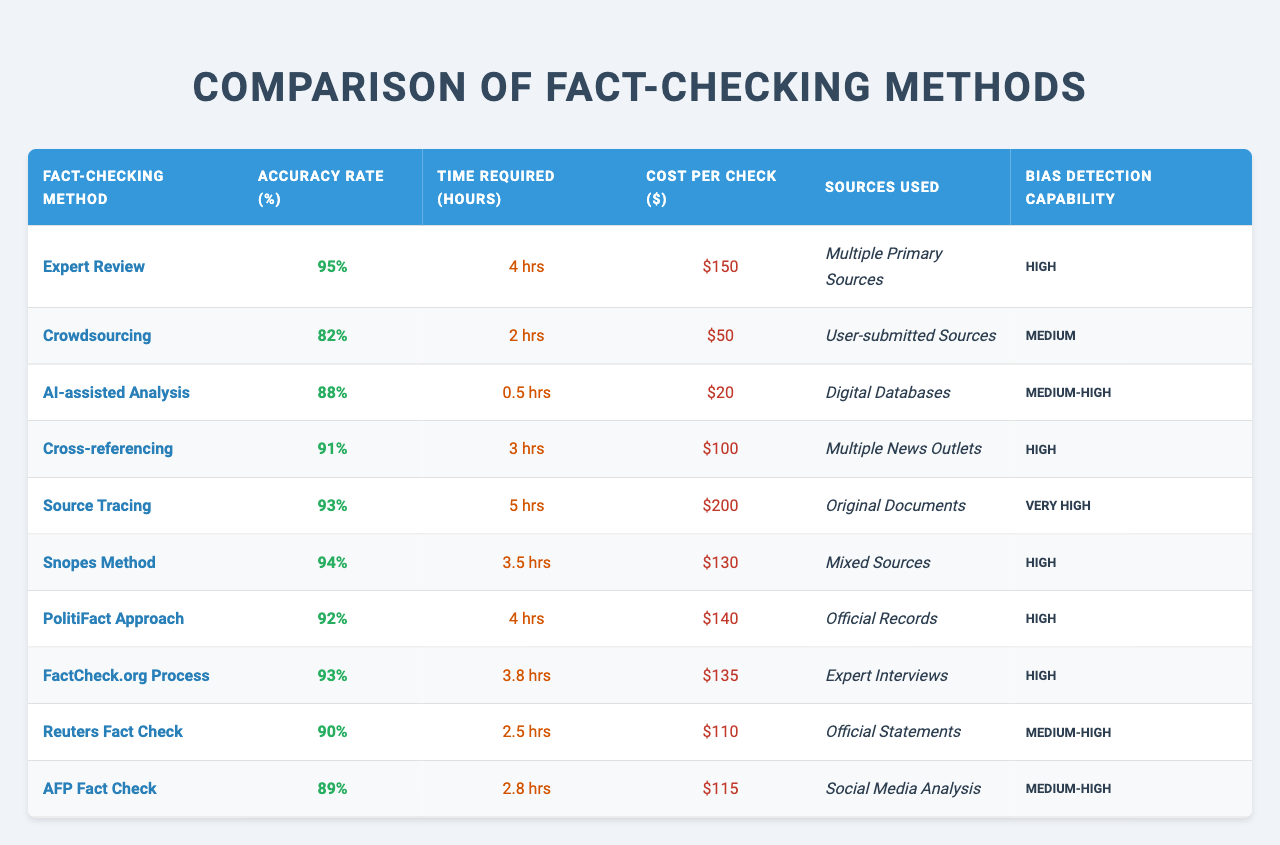What is the accuracy rate of the "Snopes Method"? The accuracy rate for the "Snopes Method" is listed in the table as 94%.
Answer: 94% How much does the "Expert Review" method cost per check? The cost per check for the "Expert Review" method is $150 as stated in the table.
Answer: $150 Which fact-checking method has the highest bias detection capability? The "Source Tracing" method has the highest bias detection capability, marked as "Very High" in the table.
Answer: Source Tracing What is the average time required for all the fact-checking methods? To find the average time, sum the hours required for each method: 4 + 2 + 0.5 + 3 + 5 + 3.5 + 4 + 3.8 + 2.5 + 2.8 = 32.6 hours. There are 10 methods, so the average is 32.6 / 10 = 3.26 hours.
Answer: 3.26 hours Is the accuracy rate of the "AI-assisted Analysis" method higher than that of "Reuters Fact Check"? "AI-assisted Analysis" has an accuracy rate of 88%, while "Reuters Fact Check" has an accuracy rate of 90%. Since 88% is less than 90%, the statement is false.
Answer: No What is the difference in accuracy rates between "Cross-referencing" and "PolitiFact Approach"? "Cross-referencing" has an accuracy rate of 91%, and "PolitiFact Approach" has an accuracy rate of 92%. The difference is 92% - 91% = 1%.
Answer: 1% Which method has the lowest cost per check, and how much is it? The "AI-assisted Analysis" method has the lowest cost per check at $20, as indicated in the table.
Answer: AI-assisted Analysis, $20 How long does it take on average for the methods that have a "High" bias detection capability? The methods with "High" bias detection capability are Expert Review, Cross-referencing, Snopes Method, PolitiFact Approach, and FactCheck.org Process. Their required hours are 4, 3, 3.5, 4, and 3.8 respectively. The total is 18.3 hours; average is 18.3 / 5 = 3.66 hours.
Answer: 3.66 hours Which method requires the least time to conduct a fact check? The method that requires the least time is "AI-assisted Analysis," which takes 0.5 hours as shown in the table.
Answer: AI-assisted Analysis Does "Crowdsourcing" have a higher accuracy rate than "AFP Fact Check"? "Crowdsourcing" has an accuracy rate of 82%, while "AFP Fact Check" has an accuracy rate of 89%. Thus, Crowdsourcing does not have a higher accuracy rate.
Answer: No 